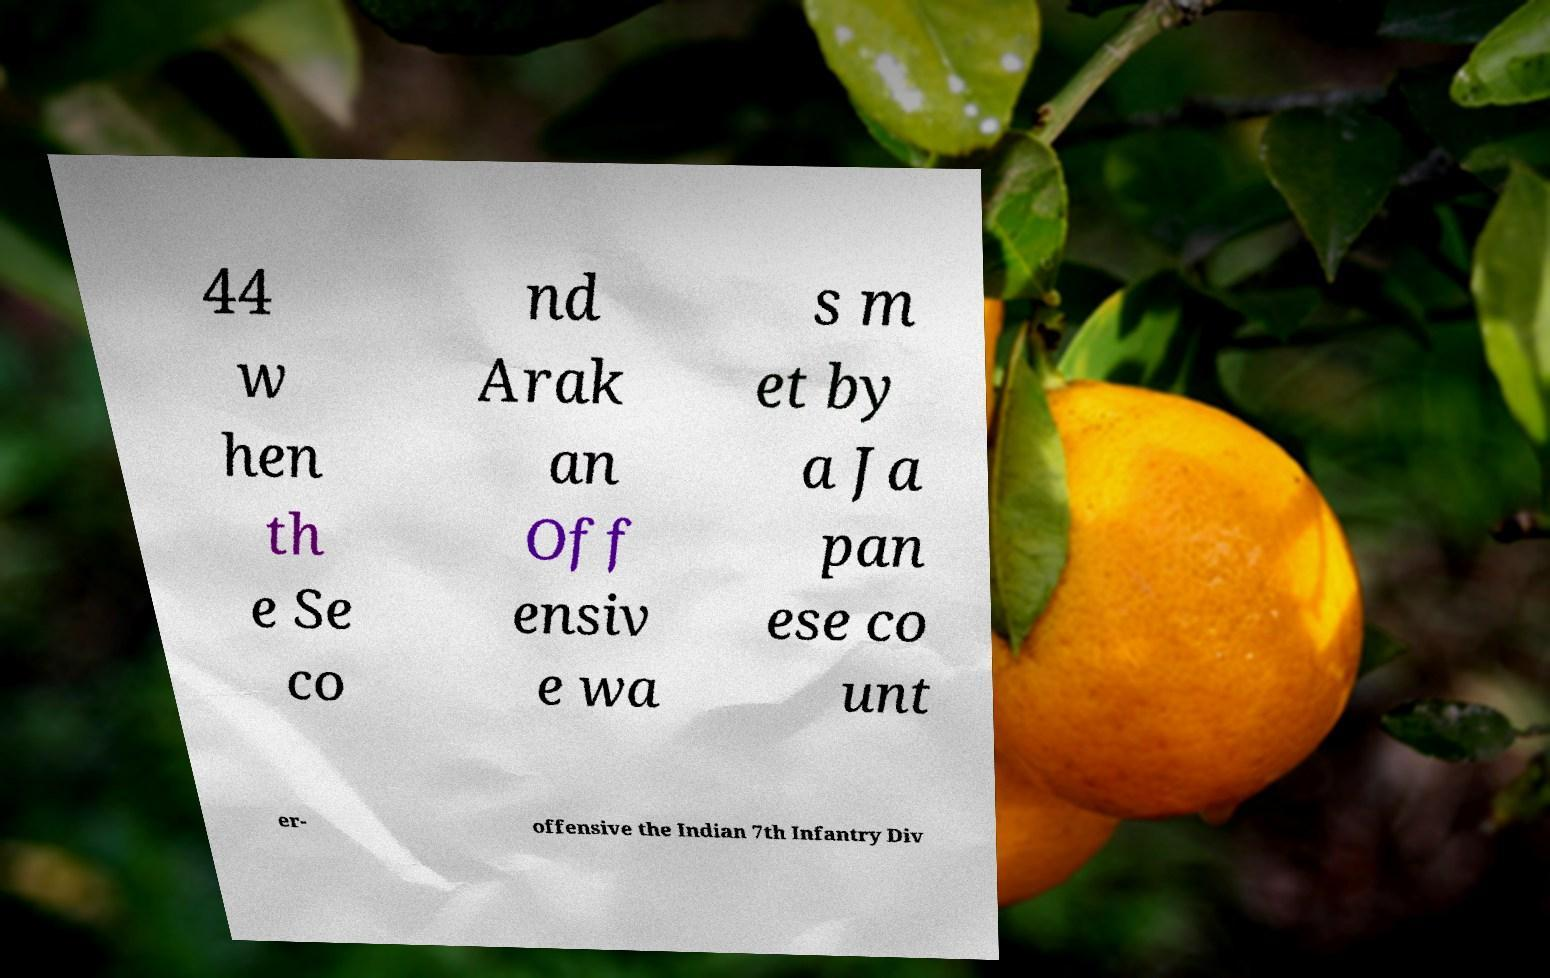For documentation purposes, I need the text within this image transcribed. Could you provide that? 44 w hen th e Se co nd Arak an Off ensiv e wa s m et by a Ja pan ese co unt er- offensive the Indian 7th Infantry Div 